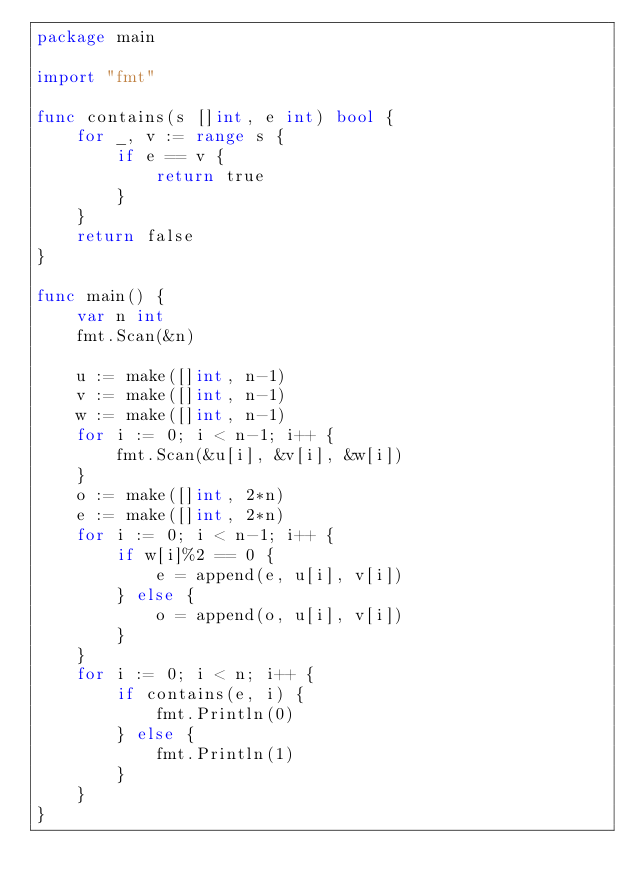<code> <loc_0><loc_0><loc_500><loc_500><_Go_>package main

import "fmt"

func contains(s []int, e int) bool {
	for _, v := range s {
		if e == v {
			return true
		}
	}
	return false
}

func main() {
	var n int
	fmt.Scan(&n)

	u := make([]int, n-1)
	v := make([]int, n-1)
	w := make([]int, n-1)
	for i := 0; i < n-1; i++ {
		fmt.Scan(&u[i], &v[i], &w[i])
	}
	o := make([]int, 2*n)
	e := make([]int, 2*n)
	for i := 0; i < n-1; i++ {
		if w[i]%2 == 0 {
			e = append(e, u[i], v[i])
		} else {
			o = append(o, u[i], v[i])
		}
	}
	for i := 0; i < n; i++ {
		if contains(e, i) {
			fmt.Println(0)
		} else {
			fmt.Println(1)
		}
	}
}
</code> 